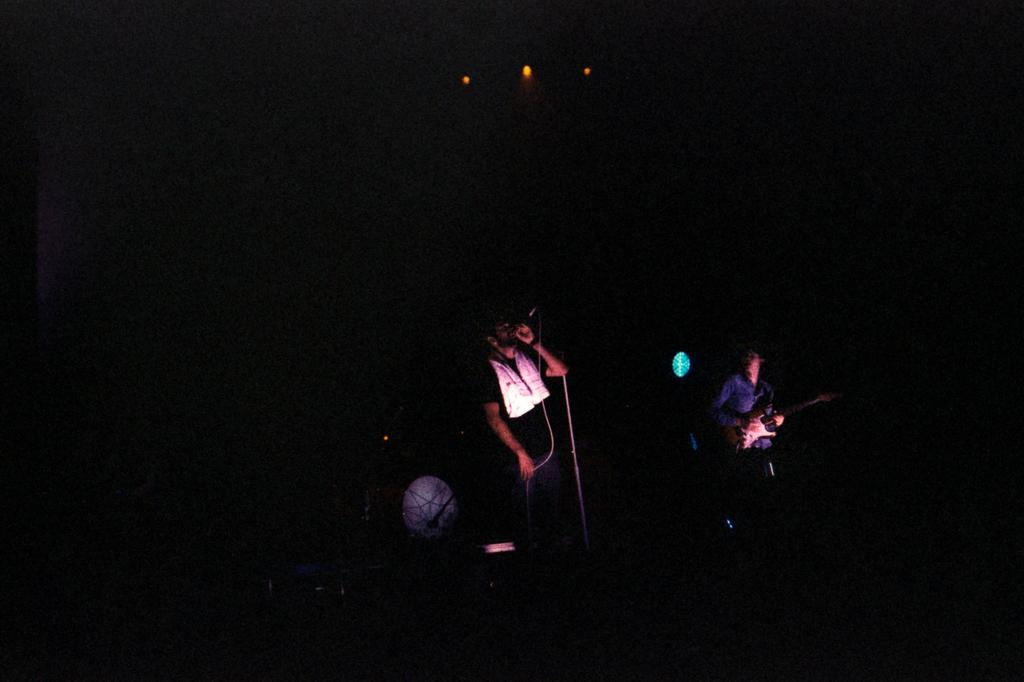What is the main subject of the image? There is a person standing in the image. What is the person holding in the image? The person is holding a microphone. Can you describe the background of the image? The background of the image is dark. What type of copper object can be seen in the image? There is no copper object present in the image. What sense is being utilized by the person holding the microphone in the image? The image does not provide information about which sense is being utilized by the person holding the microphone. 